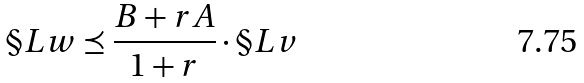Convert formula to latex. <formula><loc_0><loc_0><loc_500><loc_500>\S L w \preceq \frac { B + r A } { 1 + r } \cdot \S L v</formula> 